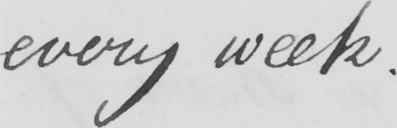Transcribe the text shown in this historical manuscript line. every week. 